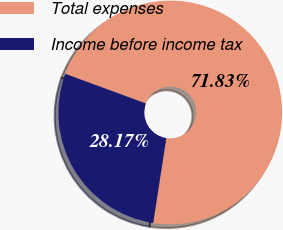<chart> <loc_0><loc_0><loc_500><loc_500><pie_chart><fcel>Total expenses<fcel>Income before income tax<nl><fcel>71.83%<fcel>28.17%<nl></chart> 